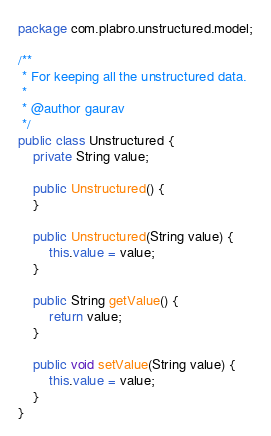Convert code to text. <code><loc_0><loc_0><loc_500><loc_500><_Java_>package com.plabro.unstructured.model;

/**
 * For keeping all the unstructured data.
 * 
 * @author gaurav
 */
public class Unstructured {
	private String value;

	public Unstructured() {
	}

	public Unstructured(String value) {
		this.value = value;
	}

	public String getValue() {
		return value;
	}

	public void setValue(String value) {
		this.value = value;
	}
}
</code> 